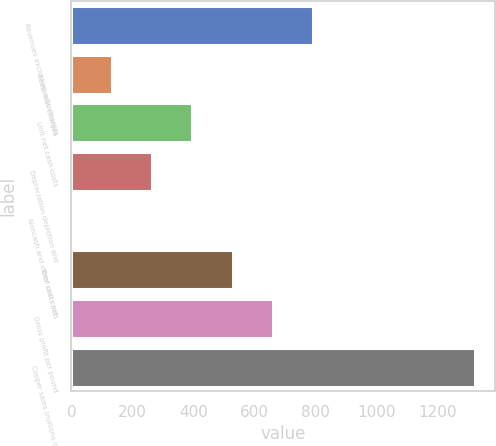Convert chart. <chart><loc_0><loc_0><loc_500><loc_500><bar_chart><fcel>Revenues excluding adjustments<fcel>Treatment charges<fcel>Unit net cash costs<fcel>Depreciation depletion and<fcel>Noncash and other costs net<fcel>Total unit costs<fcel>Gross profit per pound<fcel>Copper sales (millions of<nl><fcel>793.2<fcel>132.25<fcel>396.63<fcel>264.44<fcel>0.06<fcel>528.82<fcel>661.01<fcel>1322<nl></chart> 